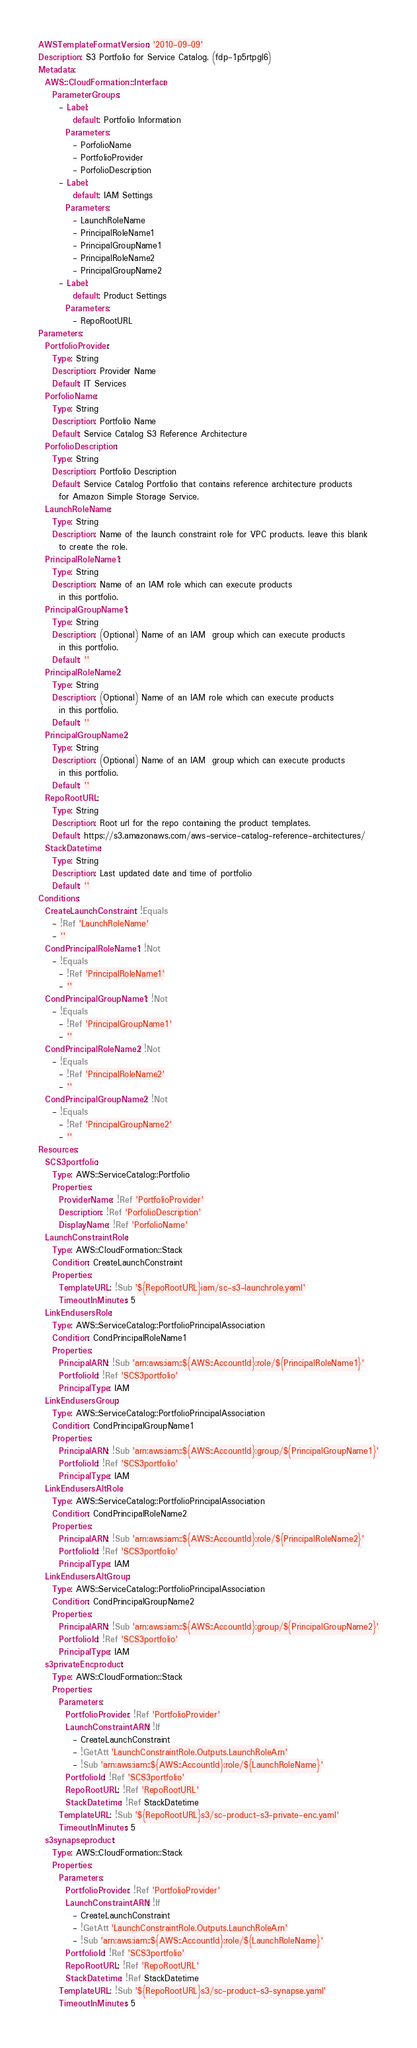Convert code to text. <code><loc_0><loc_0><loc_500><loc_500><_YAML_>AWSTemplateFormatVersion: '2010-09-09'
Description: S3 Portfolio for Service Catalog. (fdp-1p5rtpgl6)
Metadata:
  AWS::CloudFormation::Interface:
    ParameterGroups:
      - Label:
          default: Portfolio Information
        Parameters:
          - PorfolioName
          - PortfolioProvider
          - PorfolioDescription
      - Label:
          default: IAM Settings
        Parameters:
          - LaunchRoleName
          - PrincipalRoleName1
          - PrincipalGroupName1
          - PrincipalRoleName2
          - PrincipalGroupName2
      - Label:
          default: Product Settings
        Parameters:
          - RepoRootURL
Parameters:
  PortfolioProvider:
    Type: String
    Description: Provider Name
    Default: IT Services
  PorfolioName:
    Type: String
    Description: Portfolio Name
    Default: Service Catalog S3 Reference Architecture
  PorfolioDescription:
    Type: String
    Description: Portfolio Description
    Default: Service Catalog Portfolio that contains reference architecture products
      for Amazon Simple Storage Service.
  LaunchRoleName:
    Type: String
    Description: Name of the launch constraint role for VPC products. leave this blank
      to create the role.
  PrincipalRoleName1:
    Type: String
    Description: Name of an IAM role which can execute products
      in this portfolio.
  PrincipalGroupName1:
    Type: String
    Description: (Optional) Name of an IAM  group which can execute products
      in this portfolio.
    Default: ''
  PrincipalRoleName2:
    Type: String
    Description: (Optional) Name of an IAM role which can execute products
      in this portfolio.
    Default: ''
  PrincipalGroupName2:
    Type: String
    Description: (Optional) Name of an IAM  group which can execute products
      in this portfolio.
    Default: ''
  RepoRootURL:
    Type: String
    Description: Root url for the repo containing the product templates.
    Default: https://s3.amazonaws.com/aws-service-catalog-reference-architectures/
  StackDatetime:
    Type: String
    Description: Last updated date and time of portfolio
    Default: ''
Conditions:
  CreateLaunchConstraint: !Equals
    - !Ref 'LaunchRoleName'
    - ''
  CondPrincipalRoleName1: !Not
    - !Equals
      - !Ref 'PrincipalRoleName1'
      - ''
  CondPrincipalGroupName1: !Not
    - !Equals
      - !Ref 'PrincipalGroupName1'
      - ''
  CondPrincipalRoleName2: !Not
    - !Equals
      - !Ref 'PrincipalRoleName2'
      - ''
  CondPrincipalGroupName2: !Not
    - !Equals
      - !Ref 'PrincipalGroupName2'
      - ''
Resources:
  SCS3portfolio:
    Type: AWS::ServiceCatalog::Portfolio
    Properties:
      ProviderName: !Ref 'PortfolioProvider'
      Description: !Ref 'PorfolioDescription'
      DisplayName: !Ref 'PorfolioName'
  LaunchConstraintRole:
    Type: AWS::CloudFormation::Stack
    Condition: CreateLaunchConstraint
    Properties:
      TemplateURL: !Sub '${RepoRootURL}iam/sc-s3-launchrole.yaml'
      TimeoutInMinutes: 5
  LinkEndusersRole:
    Type: AWS::ServiceCatalog::PortfolioPrincipalAssociation
    Condition: CondPrincipalRoleName1
    Properties:
      PrincipalARN: !Sub 'arn:aws:iam::${AWS::AccountId}:role/${PrincipalRoleName1}'
      PortfolioId: !Ref 'SCS3portfolio'
      PrincipalType: IAM
  LinkEndusersGroup:
    Type: AWS::ServiceCatalog::PortfolioPrincipalAssociation
    Condition: CondPrincipalGroupName1
    Properties:
      PrincipalARN: !Sub 'arn:aws:iam::${AWS::AccountId}:group/${PrincipalGroupName1}'
      PortfolioId: !Ref 'SCS3portfolio'
      PrincipalType: IAM
  LinkEndusersAltRole:
    Type: AWS::ServiceCatalog::PortfolioPrincipalAssociation
    Condition: CondPrincipalRoleName2
    Properties:
      PrincipalARN: !Sub 'arn:aws:iam::${AWS::AccountId}:role/${PrincipalRoleName2}'
      PortfolioId: !Ref 'SCS3portfolio'
      PrincipalType: IAM
  LinkEndusersAltGroup:
    Type: AWS::ServiceCatalog::PortfolioPrincipalAssociation
    Condition: CondPrincipalGroupName2
    Properties:
      PrincipalARN: !Sub 'arn:aws:iam::${AWS::AccountId}:group/${PrincipalGroupName2}'
      PortfolioId: !Ref 'SCS3portfolio'
      PrincipalType: IAM
  s3privateEncproduct:
    Type: AWS::CloudFormation::Stack
    Properties:
      Parameters:
        PortfolioProvider: !Ref 'PortfolioProvider'
        LaunchConstraintARN: !If
          - CreateLaunchConstraint
          - !GetAtt 'LaunchConstraintRole.Outputs.LaunchRoleArn'
          - !Sub 'arn:aws:iam::${AWS::AccountId}:role/${LaunchRoleName}'
        PortfolioId: !Ref 'SCS3portfolio'
        RepoRootURL: !Ref 'RepoRootURL'
        StackDatetime: !Ref StackDatetime
      TemplateURL: !Sub '${RepoRootURL}s3/sc-product-s3-private-enc.yaml'
      TimeoutInMinutes: 5
  s3synapseproduct:
    Type: AWS::CloudFormation::Stack
    Properties:
      Parameters:
        PortfolioProvider: !Ref 'PortfolioProvider'
        LaunchConstraintARN: !If
          - CreateLaunchConstraint
          - !GetAtt 'LaunchConstraintRole.Outputs.LaunchRoleArn'
          - !Sub 'arn:aws:iam::${AWS::AccountId}:role/${LaunchRoleName}'
        PortfolioId: !Ref 'SCS3portfolio'
        RepoRootURL: !Ref 'RepoRootURL'
        StackDatetime: !Ref StackDatetime
      TemplateURL: !Sub '${RepoRootURL}s3/sc-product-s3-synapse.yaml'
      TimeoutInMinutes: 5
</code> 